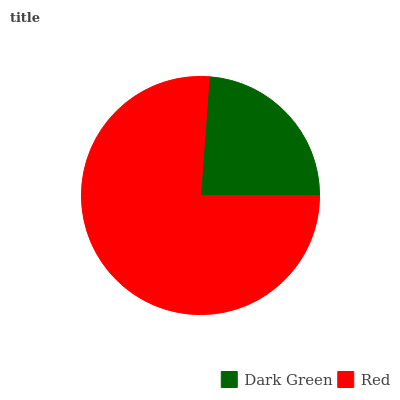Is Dark Green the minimum?
Answer yes or no. Yes. Is Red the maximum?
Answer yes or no. Yes. Is Red the minimum?
Answer yes or no. No. Is Red greater than Dark Green?
Answer yes or no. Yes. Is Dark Green less than Red?
Answer yes or no. Yes. Is Dark Green greater than Red?
Answer yes or no. No. Is Red less than Dark Green?
Answer yes or no. No. Is Red the high median?
Answer yes or no. Yes. Is Dark Green the low median?
Answer yes or no. Yes. Is Dark Green the high median?
Answer yes or no. No. Is Red the low median?
Answer yes or no. No. 